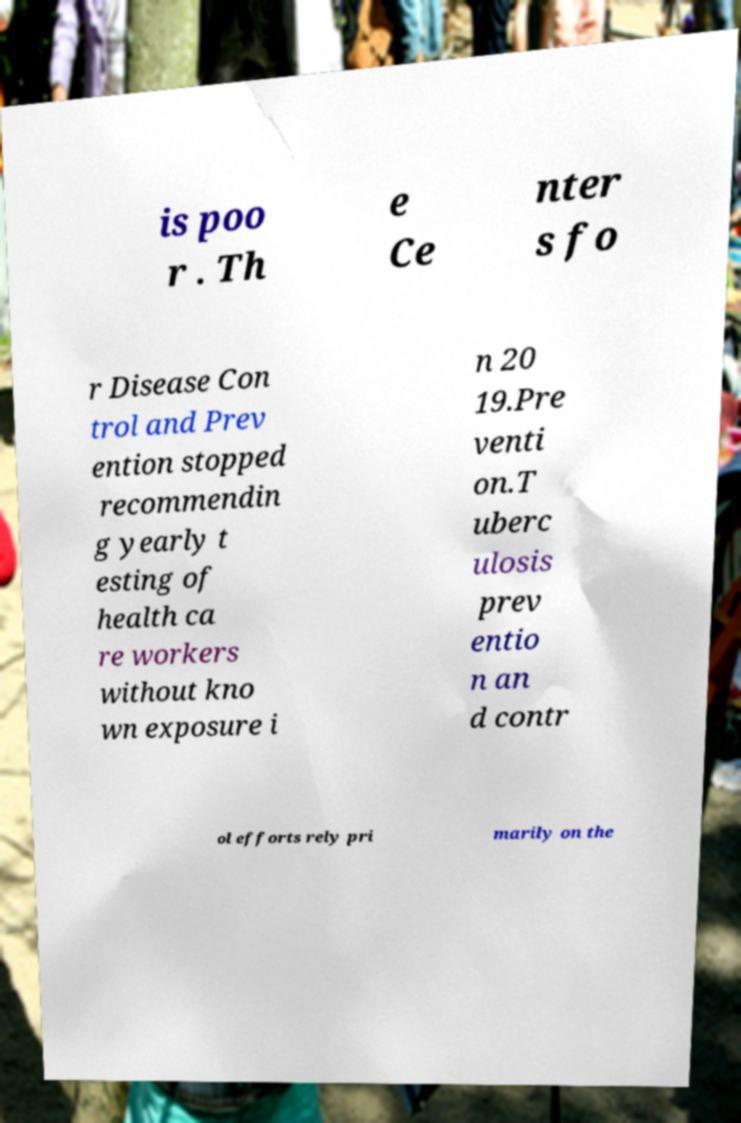Could you assist in decoding the text presented in this image and type it out clearly? is poo r . Th e Ce nter s fo r Disease Con trol and Prev ention stopped recommendin g yearly t esting of health ca re workers without kno wn exposure i n 20 19.Pre venti on.T uberc ulosis prev entio n an d contr ol efforts rely pri marily on the 